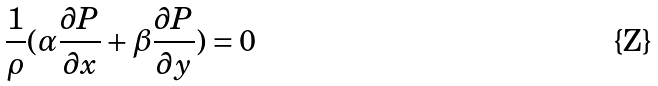Convert formula to latex. <formula><loc_0><loc_0><loc_500><loc_500>\frac { 1 } { \rho } ( \alpha \frac { \partial P } { \partial x } + \beta \frac { \partial P } { \partial y } ) = 0</formula> 